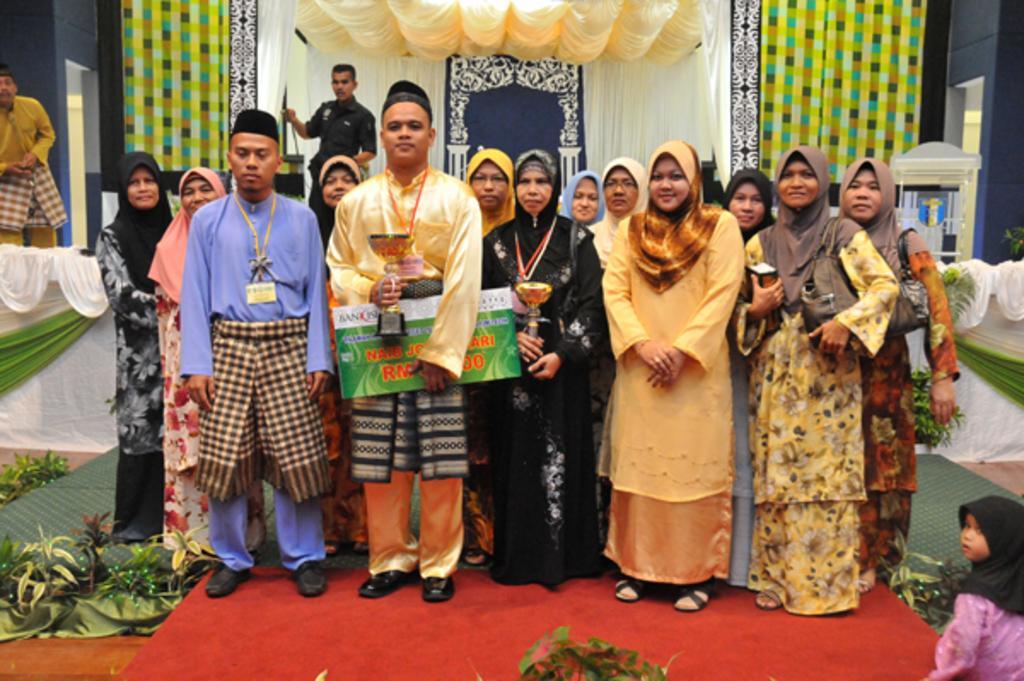Please provide a concise description of this image. In this image I can see group of people standing. In front the person is holding a shield and a board and the board is in white and green color. Background I can see few curtains in green and cream color and I can see few plants in green color and the wall is in gray color. 